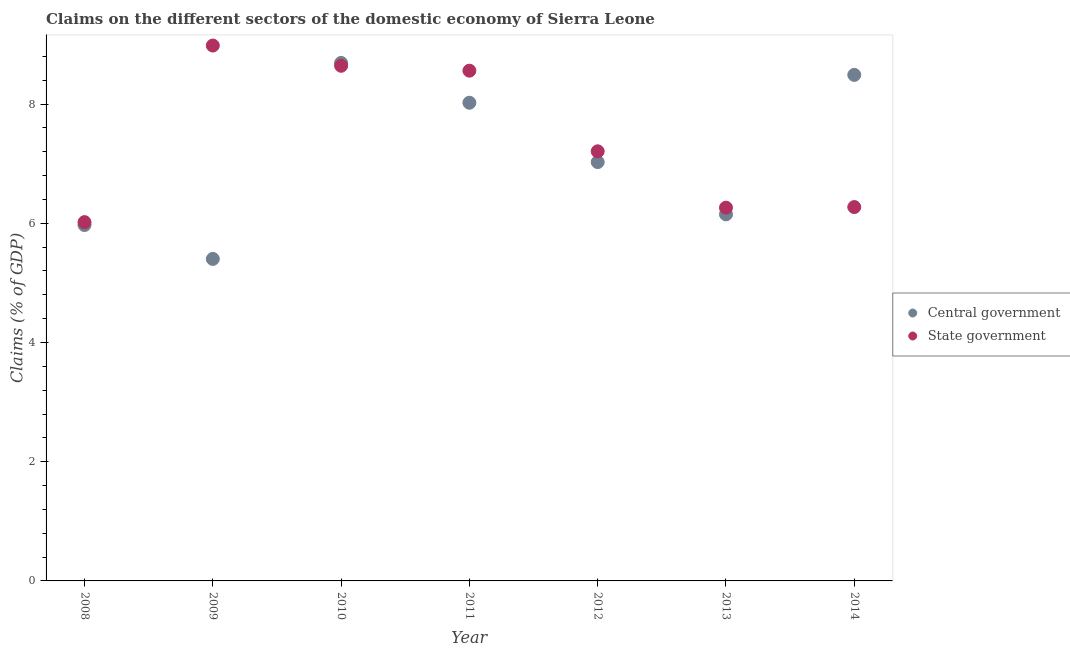How many different coloured dotlines are there?
Your answer should be compact. 2. What is the claims on state government in 2012?
Provide a succinct answer. 7.21. Across all years, what is the maximum claims on state government?
Offer a terse response. 8.98. Across all years, what is the minimum claims on state government?
Offer a terse response. 6.02. What is the total claims on state government in the graph?
Your answer should be compact. 51.95. What is the difference between the claims on central government in 2008 and that in 2010?
Make the answer very short. -2.72. What is the difference between the claims on state government in 2011 and the claims on central government in 2009?
Provide a succinct answer. 3.16. What is the average claims on central government per year?
Your response must be concise. 7.11. In the year 2009, what is the difference between the claims on state government and claims on central government?
Give a very brief answer. 3.58. In how many years, is the claims on central government greater than 1.6 %?
Give a very brief answer. 7. What is the ratio of the claims on state government in 2009 to that in 2011?
Your answer should be compact. 1.05. Is the difference between the claims on central government in 2012 and 2013 greater than the difference between the claims on state government in 2012 and 2013?
Keep it short and to the point. No. What is the difference between the highest and the second highest claims on state government?
Provide a succinct answer. 0.34. What is the difference between the highest and the lowest claims on state government?
Offer a terse response. 2.96. Does the claims on state government monotonically increase over the years?
Offer a terse response. No. Is the claims on central government strictly less than the claims on state government over the years?
Your answer should be very brief. No. How many years are there in the graph?
Make the answer very short. 7. What is the difference between two consecutive major ticks on the Y-axis?
Keep it short and to the point. 2. Does the graph contain any zero values?
Your answer should be compact. No. Does the graph contain grids?
Provide a short and direct response. No. Where does the legend appear in the graph?
Offer a terse response. Center right. How many legend labels are there?
Provide a short and direct response. 2. How are the legend labels stacked?
Your answer should be very brief. Vertical. What is the title of the graph?
Make the answer very short. Claims on the different sectors of the domestic economy of Sierra Leone. Does "Drinking water services" appear as one of the legend labels in the graph?
Provide a succinct answer. No. What is the label or title of the X-axis?
Offer a terse response. Year. What is the label or title of the Y-axis?
Ensure brevity in your answer.  Claims (% of GDP). What is the Claims (% of GDP) in Central government in 2008?
Your response must be concise. 5.97. What is the Claims (% of GDP) of State government in 2008?
Ensure brevity in your answer.  6.02. What is the Claims (% of GDP) in Central government in 2009?
Give a very brief answer. 5.4. What is the Claims (% of GDP) in State government in 2009?
Make the answer very short. 8.98. What is the Claims (% of GDP) in Central government in 2010?
Your answer should be very brief. 8.69. What is the Claims (% of GDP) of State government in 2010?
Your response must be concise. 8.64. What is the Claims (% of GDP) in Central government in 2011?
Make the answer very short. 8.02. What is the Claims (% of GDP) of State government in 2011?
Keep it short and to the point. 8.56. What is the Claims (% of GDP) of Central government in 2012?
Your response must be concise. 7.03. What is the Claims (% of GDP) of State government in 2012?
Give a very brief answer. 7.21. What is the Claims (% of GDP) in Central government in 2013?
Provide a succinct answer. 6.15. What is the Claims (% of GDP) of State government in 2013?
Your response must be concise. 6.26. What is the Claims (% of GDP) of Central government in 2014?
Ensure brevity in your answer.  8.49. What is the Claims (% of GDP) in State government in 2014?
Ensure brevity in your answer.  6.27. Across all years, what is the maximum Claims (% of GDP) of Central government?
Make the answer very short. 8.69. Across all years, what is the maximum Claims (% of GDP) of State government?
Keep it short and to the point. 8.98. Across all years, what is the minimum Claims (% of GDP) of Central government?
Ensure brevity in your answer.  5.4. Across all years, what is the minimum Claims (% of GDP) of State government?
Your response must be concise. 6.02. What is the total Claims (% of GDP) of Central government in the graph?
Your answer should be compact. 49.76. What is the total Claims (% of GDP) of State government in the graph?
Provide a succinct answer. 51.95. What is the difference between the Claims (% of GDP) in Central government in 2008 and that in 2009?
Your answer should be compact. 0.57. What is the difference between the Claims (% of GDP) of State government in 2008 and that in 2009?
Your answer should be very brief. -2.96. What is the difference between the Claims (% of GDP) of Central government in 2008 and that in 2010?
Your response must be concise. -2.72. What is the difference between the Claims (% of GDP) of State government in 2008 and that in 2010?
Make the answer very short. -2.62. What is the difference between the Claims (% of GDP) of Central government in 2008 and that in 2011?
Give a very brief answer. -2.05. What is the difference between the Claims (% of GDP) of State government in 2008 and that in 2011?
Ensure brevity in your answer.  -2.54. What is the difference between the Claims (% of GDP) of Central government in 2008 and that in 2012?
Your answer should be very brief. -1.06. What is the difference between the Claims (% of GDP) in State government in 2008 and that in 2012?
Make the answer very short. -1.19. What is the difference between the Claims (% of GDP) in Central government in 2008 and that in 2013?
Offer a very short reply. -0.18. What is the difference between the Claims (% of GDP) of State government in 2008 and that in 2013?
Provide a short and direct response. -0.24. What is the difference between the Claims (% of GDP) in Central government in 2008 and that in 2014?
Your response must be concise. -2.52. What is the difference between the Claims (% of GDP) of State government in 2008 and that in 2014?
Make the answer very short. -0.25. What is the difference between the Claims (% of GDP) of Central government in 2009 and that in 2010?
Your answer should be compact. -3.29. What is the difference between the Claims (% of GDP) in State government in 2009 and that in 2010?
Offer a terse response. 0.34. What is the difference between the Claims (% of GDP) in Central government in 2009 and that in 2011?
Your answer should be very brief. -2.62. What is the difference between the Claims (% of GDP) of State government in 2009 and that in 2011?
Your response must be concise. 0.42. What is the difference between the Claims (% of GDP) in Central government in 2009 and that in 2012?
Provide a short and direct response. -1.62. What is the difference between the Claims (% of GDP) in State government in 2009 and that in 2012?
Make the answer very short. 1.77. What is the difference between the Claims (% of GDP) of Central government in 2009 and that in 2013?
Give a very brief answer. -0.75. What is the difference between the Claims (% of GDP) in State government in 2009 and that in 2013?
Your response must be concise. 2.72. What is the difference between the Claims (% of GDP) of Central government in 2009 and that in 2014?
Keep it short and to the point. -3.09. What is the difference between the Claims (% of GDP) of State government in 2009 and that in 2014?
Your answer should be very brief. 2.71. What is the difference between the Claims (% of GDP) in Central government in 2010 and that in 2011?
Offer a very short reply. 0.67. What is the difference between the Claims (% of GDP) in State government in 2010 and that in 2011?
Provide a succinct answer. 0.08. What is the difference between the Claims (% of GDP) in Central government in 2010 and that in 2012?
Give a very brief answer. 1.66. What is the difference between the Claims (% of GDP) in State government in 2010 and that in 2012?
Your answer should be very brief. 1.44. What is the difference between the Claims (% of GDP) of Central government in 2010 and that in 2013?
Provide a succinct answer. 2.54. What is the difference between the Claims (% of GDP) in State government in 2010 and that in 2013?
Provide a short and direct response. 2.38. What is the difference between the Claims (% of GDP) in Central government in 2010 and that in 2014?
Your answer should be compact. 0.2. What is the difference between the Claims (% of GDP) of State government in 2010 and that in 2014?
Ensure brevity in your answer.  2.37. What is the difference between the Claims (% of GDP) in Central government in 2011 and that in 2012?
Ensure brevity in your answer.  1. What is the difference between the Claims (% of GDP) in State government in 2011 and that in 2012?
Ensure brevity in your answer.  1.35. What is the difference between the Claims (% of GDP) of Central government in 2011 and that in 2013?
Your response must be concise. 1.87. What is the difference between the Claims (% of GDP) of State government in 2011 and that in 2013?
Offer a terse response. 2.3. What is the difference between the Claims (% of GDP) in Central government in 2011 and that in 2014?
Make the answer very short. -0.47. What is the difference between the Claims (% of GDP) of State government in 2011 and that in 2014?
Provide a succinct answer. 2.29. What is the difference between the Claims (% of GDP) of Central government in 2012 and that in 2013?
Your answer should be very brief. 0.88. What is the difference between the Claims (% of GDP) in State government in 2012 and that in 2013?
Provide a short and direct response. 0.95. What is the difference between the Claims (% of GDP) of Central government in 2012 and that in 2014?
Make the answer very short. -1.46. What is the difference between the Claims (% of GDP) of State government in 2012 and that in 2014?
Your answer should be compact. 0.94. What is the difference between the Claims (% of GDP) in Central government in 2013 and that in 2014?
Offer a terse response. -2.34. What is the difference between the Claims (% of GDP) of State government in 2013 and that in 2014?
Keep it short and to the point. -0.01. What is the difference between the Claims (% of GDP) of Central government in 2008 and the Claims (% of GDP) of State government in 2009?
Keep it short and to the point. -3.01. What is the difference between the Claims (% of GDP) in Central government in 2008 and the Claims (% of GDP) in State government in 2010?
Offer a terse response. -2.67. What is the difference between the Claims (% of GDP) in Central government in 2008 and the Claims (% of GDP) in State government in 2011?
Give a very brief answer. -2.59. What is the difference between the Claims (% of GDP) in Central government in 2008 and the Claims (% of GDP) in State government in 2012?
Provide a succinct answer. -1.24. What is the difference between the Claims (% of GDP) of Central government in 2008 and the Claims (% of GDP) of State government in 2013?
Provide a short and direct response. -0.29. What is the difference between the Claims (% of GDP) in Central government in 2008 and the Claims (% of GDP) in State government in 2014?
Make the answer very short. -0.3. What is the difference between the Claims (% of GDP) of Central government in 2009 and the Claims (% of GDP) of State government in 2010?
Ensure brevity in your answer.  -3.24. What is the difference between the Claims (% of GDP) of Central government in 2009 and the Claims (% of GDP) of State government in 2011?
Your answer should be compact. -3.16. What is the difference between the Claims (% of GDP) in Central government in 2009 and the Claims (% of GDP) in State government in 2012?
Provide a short and direct response. -1.81. What is the difference between the Claims (% of GDP) of Central government in 2009 and the Claims (% of GDP) of State government in 2013?
Your response must be concise. -0.86. What is the difference between the Claims (% of GDP) in Central government in 2009 and the Claims (% of GDP) in State government in 2014?
Provide a succinct answer. -0.87. What is the difference between the Claims (% of GDP) in Central government in 2010 and the Claims (% of GDP) in State government in 2011?
Give a very brief answer. 0.13. What is the difference between the Claims (% of GDP) of Central government in 2010 and the Claims (% of GDP) of State government in 2012?
Give a very brief answer. 1.48. What is the difference between the Claims (% of GDP) of Central government in 2010 and the Claims (% of GDP) of State government in 2013?
Offer a very short reply. 2.43. What is the difference between the Claims (% of GDP) in Central government in 2010 and the Claims (% of GDP) in State government in 2014?
Your answer should be compact. 2.42. What is the difference between the Claims (% of GDP) of Central government in 2011 and the Claims (% of GDP) of State government in 2012?
Your answer should be compact. 0.81. What is the difference between the Claims (% of GDP) of Central government in 2011 and the Claims (% of GDP) of State government in 2013?
Provide a succinct answer. 1.76. What is the difference between the Claims (% of GDP) in Central government in 2011 and the Claims (% of GDP) in State government in 2014?
Keep it short and to the point. 1.75. What is the difference between the Claims (% of GDP) in Central government in 2012 and the Claims (% of GDP) in State government in 2013?
Offer a terse response. 0.76. What is the difference between the Claims (% of GDP) of Central government in 2012 and the Claims (% of GDP) of State government in 2014?
Offer a terse response. 0.75. What is the difference between the Claims (% of GDP) of Central government in 2013 and the Claims (% of GDP) of State government in 2014?
Give a very brief answer. -0.12. What is the average Claims (% of GDP) of Central government per year?
Provide a short and direct response. 7.11. What is the average Claims (% of GDP) of State government per year?
Offer a terse response. 7.42. In the year 2008, what is the difference between the Claims (% of GDP) of Central government and Claims (% of GDP) of State government?
Your answer should be compact. -0.05. In the year 2009, what is the difference between the Claims (% of GDP) in Central government and Claims (% of GDP) in State government?
Offer a terse response. -3.58. In the year 2010, what is the difference between the Claims (% of GDP) in Central government and Claims (% of GDP) in State government?
Your answer should be compact. 0.05. In the year 2011, what is the difference between the Claims (% of GDP) in Central government and Claims (% of GDP) in State government?
Provide a short and direct response. -0.54. In the year 2012, what is the difference between the Claims (% of GDP) in Central government and Claims (% of GDP) in State government?
Provide a succinct answer. -0.18. In the year 2013, what is the difference between the Claims (% of GDP) in Central government and Claims (% of GDP) in State government?
Offer a very short reply. -0.11. In the year 2014, what is the difference between the Claims (% of GDP) in Central government and Claims (% of GDP) in State government?
Offer a terse response. 2.22. What is the ratio of the Claims (% of GDP) of Central government in 2008 to that in 2009?
Your answer should be compact. 1.11. What is the ratio of the Claims (% of GDP) in State government in 2008 to that in 2009?
Your response must be concise. 0.67. What is the ratio of the Claims (% of GDP) in Central government in 2008 to that in 2010?
Your answer should be compact. 0.69. What is the ratio of the Claims (% of GDP) of State government in 2008 to that in 2010?
Your response must be concise. 0.7. What is the ratio of the Claims (% of GDP) in Central government in 2008 to that in 2011?
Provide a succinct answer. 0.74. What is the ratio of the Claims (% of GDP) of State government in 2008 to that in 2011?
Your answer should be compact. 0.7. What is the ratio of the Claims (% of GDP) of Central government in 2008 to that in 2012?
Make the answer very short. 0.85. What is the ratio of the Claims (% of GDP) in State government in 2008 to that in 2012?
Keep it short and to the point. 0.84. What is the ratio of the Claims (% of GDP) of Central government in 2008 to that in 2013?
Ensure brevity in your answer.  0.97. What is the ratio of the Claims (% of GDP) in State government in 2008 to that in 2013?
Offer a very short reply. 0.96. What is the ratio of the Claims (% of GDP) of Central government in 2008 to that in 2014?
Offer a terse response. 0.7. What is the ratio of the Claims (% of GDP) of State government in 2008 to that in 2014?
Ensure brevity in your answer.  0.96. What is the ratio of the Claims (% of GDP) of Central government in 2009 to that in 2010?
Ensure brevity in your answer.  0.62. What is the ratio of the Claims (% of GDP) in State government in 2009 to that in 2010?
Provide a succinct answer. 1.04. What is the ratio of the Claims (% of GDP) of Central government in 2009 to that in 2011?
Ensure brevity in your answer.  0.67. What is the ratio of the Claims (% of GDP) in State government in 2009 to that in 2011?
Provide a succinct answer. 1.05. What is the ratio of the Claims (% of GDP) in Central government in 2009 to that in 2012?
Your answer should be compact. 0.77. What is the ratio of the Claims (% of GDP) in State government in 2009 to that in 2012?
Provide a short and direct response. 1.25. What is the ratio of the Claims (% of GDP) in Central government in 2009 to that in 2013?
Offer a very short reply. 0.88. What is the ratio of the Claims (% of GDP) in State government in 2009 to that in 2013?
Offer a terse response. 1.43. What is the ratio of the Claims (% of GDP) of Central government in 2009 to that in 2014?
Your answer should be very brief. 0.64. What is the ratio of the Claims (% of GDP) in State government in 2009 to that in 2014?
Your response must be concise. 1.43. What is the ratio of the Claims (% of GDP) of State government in 2010 to that in 2011?
Provide a succinct answer. 1.01. What is the ratio of the Claims (% of GDP) in Central government in 2010 to that in 2012?
Your response must be concise. 1.24. What is the ratio of the Claims (% of GDP) in State government in 2010 to that in 2012?
Your answer should be compact. 1.2. What is the ratio of the Claims (% of GDP) of Central government in 2010 to that in 2013?
Provide a short and direct response. 1.41. What is the ratio of the Claims (% of GDP) in State government in 2010 to that in 2013?
Make the answer very short. 1.38. What is the ratio of the Claims (% of GDP) of Central government in 2010 to that in 2014?
Ensure brevity in your answer.  1.02. What is the ratio of the Claims (% of GDP) of State government in 2010 to that in 2014?
Give a very brief answer. 1.38. What is the ratio of the Claims (% of GDP) in Central government in 2011 to that in 2012?
Keep it short and to the point. 1.14. What is the ratio of the Claims (% of GDP) of State government in 2011 to that in 2012?
Your answer should be compact. 1.19. What is the ratio of the Claims (% of GDP) of Central government in 2011 to that in 2013?
Offer a very short reply. 1.3. What is the ratio of the Claims (% of GDP) of State government in 2011 to that in 2013?
Give a very brief answer. 1.37. What is the ratio of the Claims (% of GDP) in Central government in 2011 to that in 2014?
Provide a succinct answer. 0.94. What is the ratio of the Claims (% of GDP) in State government in 2011 to that in 2014?
Provide a short and direct response. 1.36. What is the ratio of the Claims (% of GDP) in Central government in 2012 to that in 2013?
Provide a succinct answer. 1.14. What is the ratio of the Claims (% of GDP) of State government in 2012 to that in 2013?
Offer a very short reply. 1.15. What is the ratio of the Claims (% of GDP) in Central government in 2012 to that in 2014?
Offer a very short reply. 0.83. What is the ratio of the Claims (% of GDP) of State government in 2012 to that in 2014?
Ensure brevity in your answer.  1.15. What is the ratio of the Claims (% of GDP) in Central government in 2013 to that in 2014?
Keep it short and to the point. 0.72. What is the ratio of the Claims (% of GDP) in State government in 2013 to that in 2014?
Ensure brevity in your answer.  1. What is the difference between the highest and the second highest Claims (% of GDP) in Central government?
Your answer should be compact. 0.2. What is the difference between the highest and the second highest Claims (% of GDP) in State government?
Provide a succinct answer. 0.34. What is the difference between the highest and the lowest Claims (% of GDP) in Central government?
Your answer should be compact. 3.29. What is the difference between the highest and the lowest Claims (% of GDP) of State government?
Make the answer very short. 2.96. 